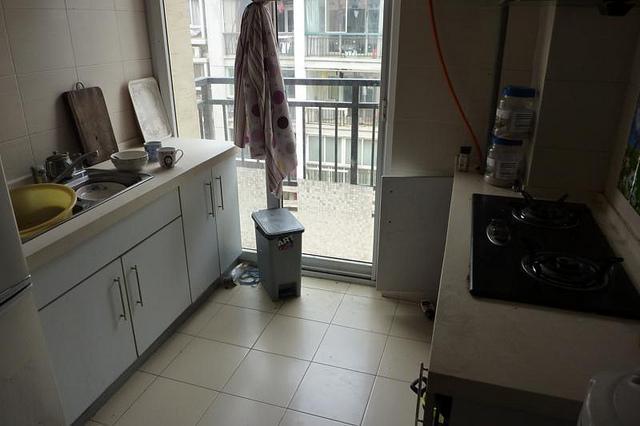How many cutting boards are shown?
Give a very brief answer. 2. How many frying pans could be used simultaneously?
Give a very brief answer. 2. How many refrigerators are there?
Give a very brief answer. 1. 